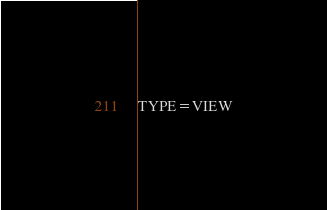<code> <loc_0><loc_0><loc_500><loc_500><_VisualBasic_>TYPE=VIEW</code> 